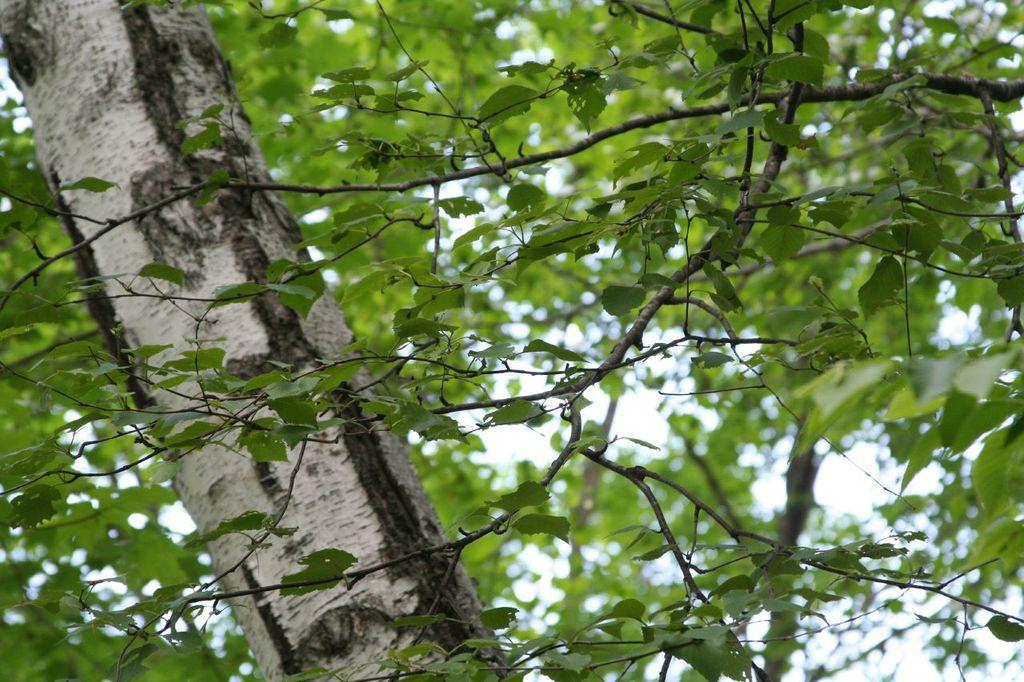What is the main subject of the image? The main subject of the image is a tree. Can you describe the tree's structure? The tree has a trunk and many branches around it. What is the purpose of the head cushion on the tree? There is no head cushion present on the tree in the image. 